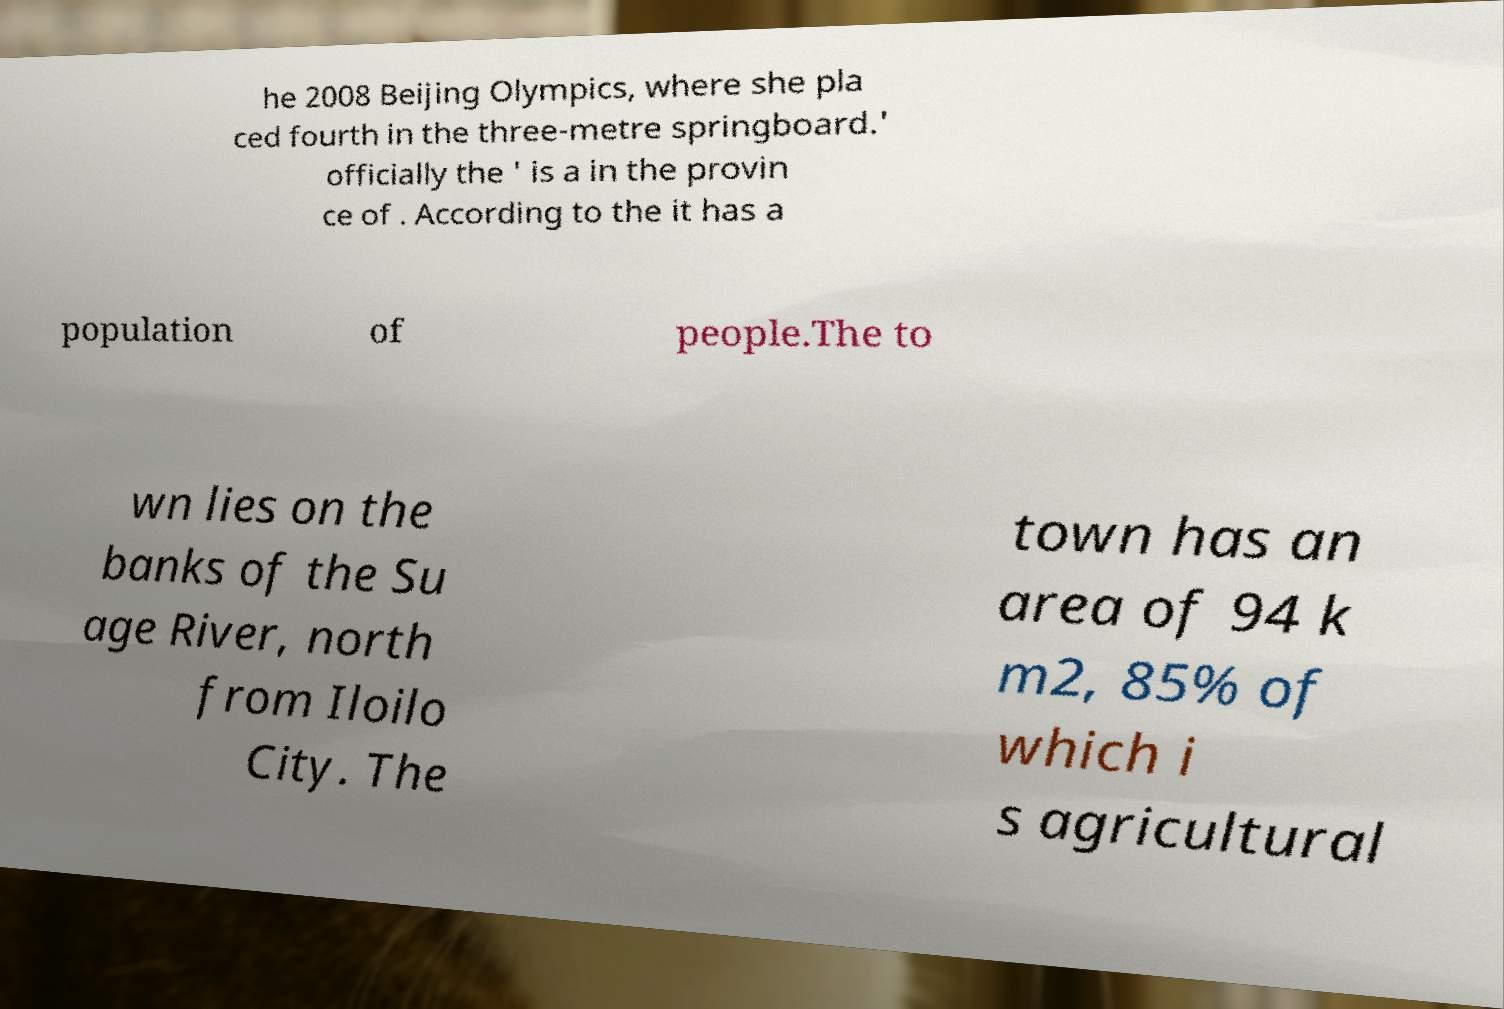Can you read and provide the text displayed in the image?This photo seems to have some interesting text. Can you extract and type it out for me? he 2008 Beijing Olympics, where she pla ced fourth in the three-metre springboard.' officially the ' is a in the provin ce of . According to the it has a population of people.The to wn lies on the banks of the Su age River, north from Iloilo City. The town has an area of 94 k m2, 85% of which i s agricultural 